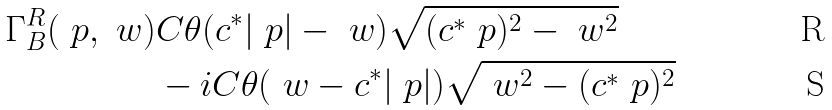<formula> <loc_0><loc_0><loc_500><loc_500>\Gamma _ { B } ^ { R } ( \ p , \ w ) & C \theta ( c ^ { * } | \ p | - \ w ) \sqrt { ( c ^ { * } \ p ) ^ { 2 } - \ w ^ { 2 } } \\ & - i C \theta ( \ w - c ^ { * } | \ p | ) \sqrt { \ w ^ { 2 } - ( c ^ { * } \ p ) ^ { 2 } }</formula> 